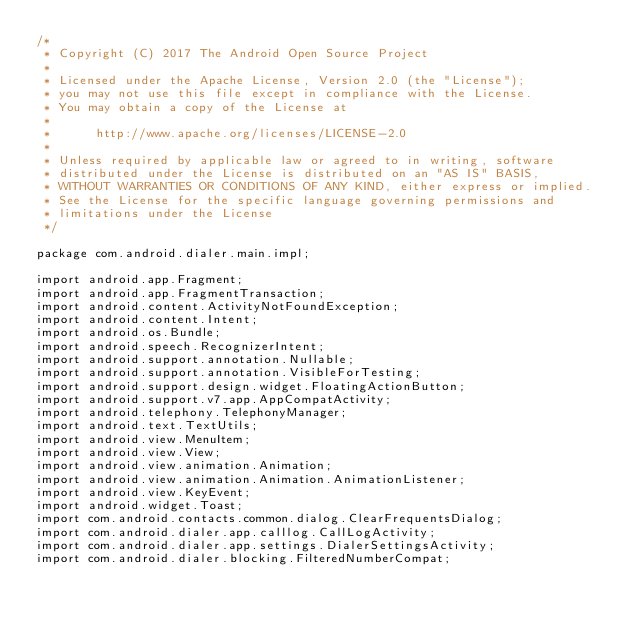<code> <loc_0><loc_0><loc_500><loc_500><_Java_>/*
 * Copyright (C) 2017 The Android Open Source Project
 *
 * Licensed under the Apache License, Version 2.0 (the "License");
 * you may not use this file except in compliance with the License.
 * You may obtain a copy of the License at
 *
 *      http://www.apache.org/licenses/LICENSE-2.0
 *
 * Unless required by applicable law or agreed to in writing, software
 * distributed under the License is distributed on an "AS IS" BASIS,
 * WITHOUT WARRANTIES OR CONDITIONS OF ANY KIND, either express or implied.
 * See the License for the specific language governing permissions and
 * limitations under the License
 */

package com.android.dialer.main.impl;

import android.app.Fragment;
import android.app.FragmentTransaction;
import android.content.ActivityNotFoundException;
import android.content.Intent;
import android.os.Bundle;
import android.speech.RecognizerIntent;
import android.support.annotation.Nullable;
import android.support.annotation.VisibleForTesting;
import android.support.design.widget.FloatingActionButton;
import android.support.v7.app.AppCompatActivity;
import android.telephony.TelephonyManager;
import android.text.TextUtils;
import android.view.MenuItem;
import android.view.View;
import android.view.animation.Animation;
import android.view.animation.Animation.AnimationListener;
import android.view.KeyEvent;
import android.widget.Toast;
import com.android.contacts.common.dialog.ClearFrequentsDialog;
import com.android.dialer.app.calllog.CallLogActivity;
import com.android.dialer.app.settings.DialerSettingsActivity;
import com.android.dialer.blocking.FilteredNumberCompat;</code> 